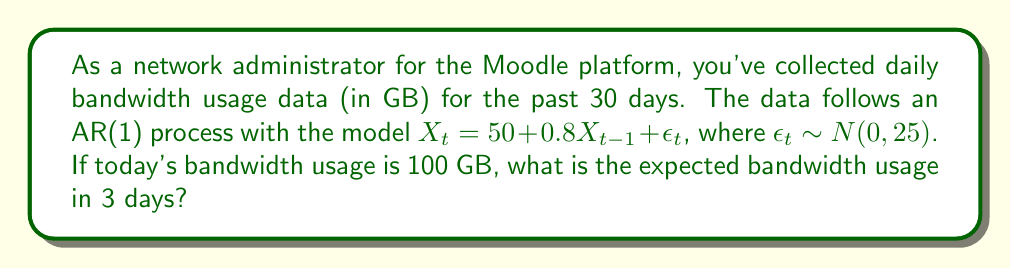Can you solve this math problem? To solve this problem, we'll use the properties of the AR(1) process and iterate the expectation for the next 3 days:

1) For an AR(1) process $X_t = c + \phi X_{t-1} + \epsilon_t$, we have:
   $c = 50$, $\phi = 0.8$, and $\epsilon_t \sim N(0, 25)$

2) The expectation for the next day (t+1) given today's value (t) is:
   $E[X_{t+1}|X_t] = c + \phi X_t$

3) Let's calculate for the next 3 days:

   Day 1: $E[X_{t+1}|X_t=100] = 50 + 0.8(100) = 130$ GB

   Day 2: $E[X_{t+2}|X_{t+1}] = 50 + 0.8(130) = 154$ GB

   Day 3: $E[X_{t+3}|X_{t+2}] = 50 + 0.8(154) = 173.2$ GB

4) Therefore, the expected bandwidth usage in 3 days is 173.2 GB.
Answer: 173.2 GB 